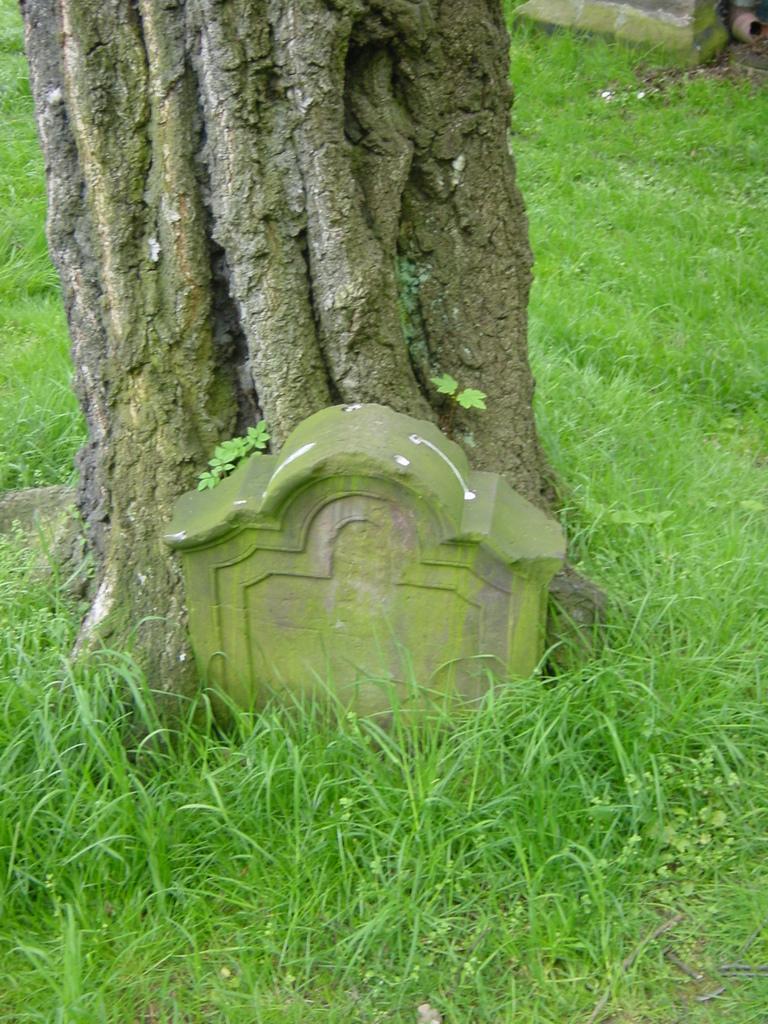Can you describe this image briefly? In the picture we can see a grass surface and a tree branch near it, we can see a grave stone and we can also see some plant saplings on the tree branch. 